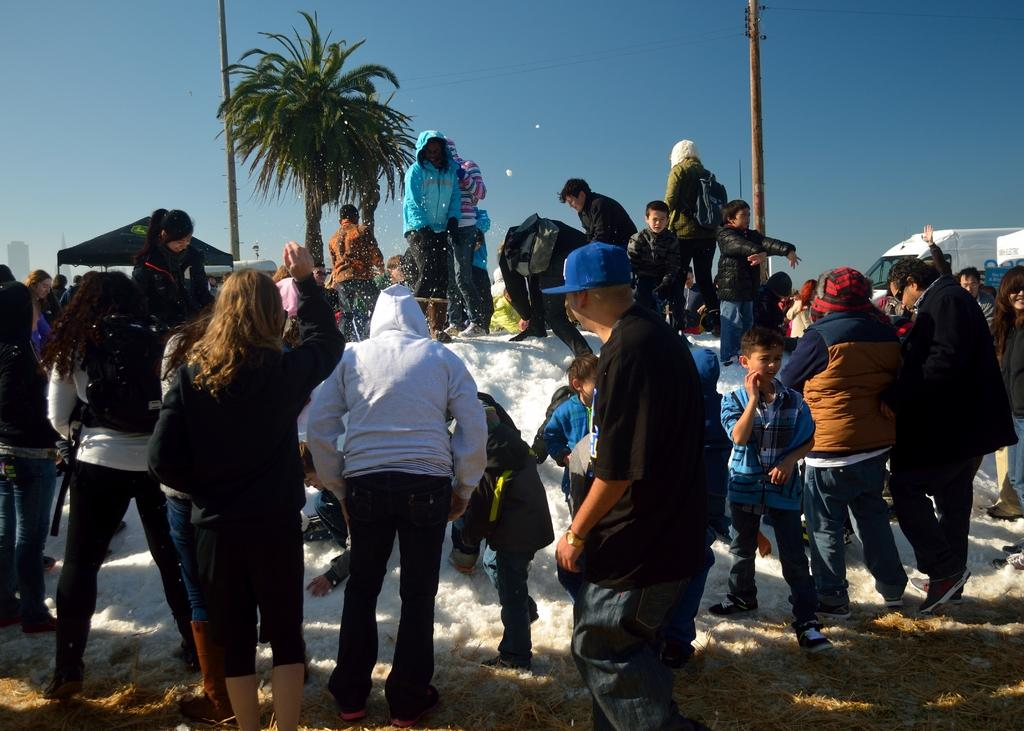What are the people in the image doing? The people in the image are standing on the ground. What can be seen in the background of the image? There is a tree, poles, the sky, a vehicle, and other objects in the background of the image. Can you describe the sky in the image? The sky is visible in the background of the image. Where is the crown placed in the image? There is no crown present in the image. Can you describe the eye color of the person in the image? There is no person in the image, only a group of people standing on the ground. 